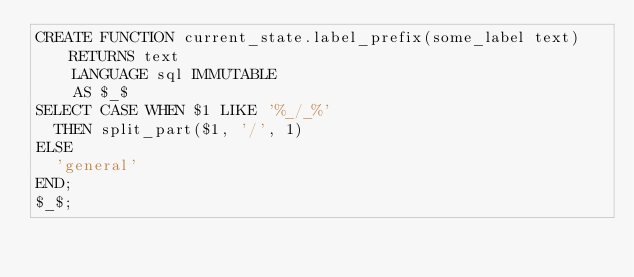Convert code to text. <code><loc_0><loc_0><loc_500><loc_500><_SQL_>CREATE FUNCTION current_state.label_prefix(some_label text) RETURNS text
    LANGUAGE sql IMMUTABLE
    AS $_$
SELECT CASE WHEN $1 LIKE '%_/_%'
  THEN split_part($1, '/', 1)
ELSE
  'general'
END;
$_$;
</code> 